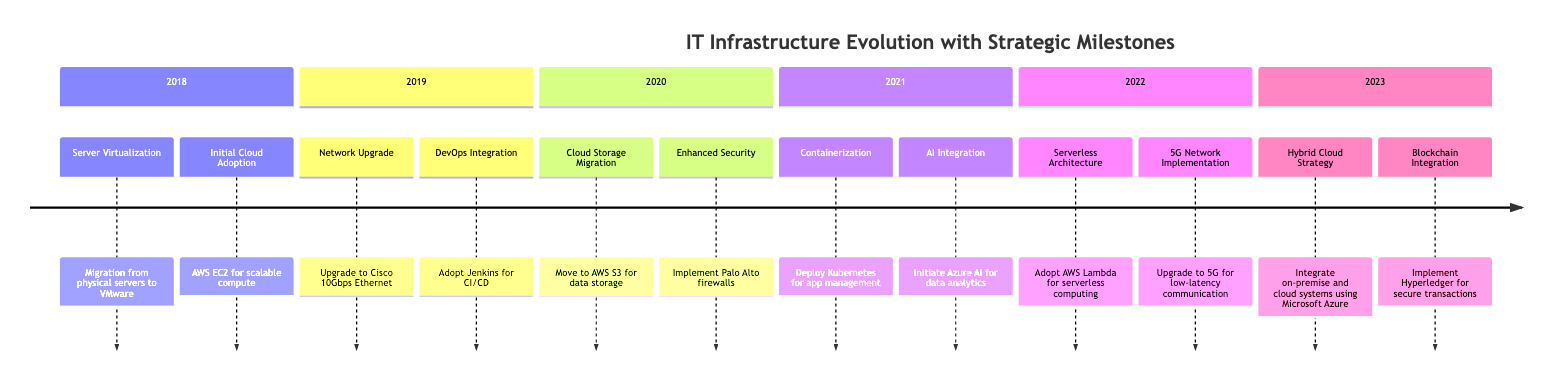What is the first key milestone in 2018? The first key milestone listed under the year 2018 is "Server Virtualization," which mentions the migration from physical servers to VMware.
Answer: Server Virtualization How many key milestones are there in 2021? In 2021, there are two key milestones indicated: "Containerization" and "AI Integration." Therefore, counting them gives a total of two milestones for that year.
Answer: 2 Which technology was adopted for serverless computing in 2022? The technology adopted for serverless computing in 2022 is indicated as "AWS Lambda," which is explicitly mentioned in the relevant section.
Answer: AWS Lambda What significant network technology was implemented in 2022? The significant network technology implemented in 2022, according to the diagram, is "5G Network Implementation," specifically aimed at achieving low-latency communication.
Answer: 5G Network Implementation In which year did cloud storage migration occur? The diagram specifies that cloud storage migration to "AWS S3 for data storage" occurred in the year 2020.
Answer: 2020 What does the hybrid cloud strategy integrate in 2023? The hybrid cloud strategy integrates "on-premise and cloud systems using Microsoft Azure," as stated in the 2023 section of the diagram.
Answer: on-premise and cloud systems using Microsoft Azure How does the 2019 milestone for network upgrade relate to DevOps integration? The 2019 milestones show "Network Upgrade" and "DevOps Integration" as separate milestones. The significance lies in both improvements enhancing system performance and development efficiency, indicating a strategy to upgrade and integrate operations.
Answer: Enhancing system performance and development efficiency What is the last technological advancement mentioned in the timeline? The last technological advancement mentioned in the timeline is "Blockchain Integration," which refers to the implementation of Hyperledger for secure transactions in the year 2023.
Answer: Blockchain Integration What approach was taken for data analytics integration in 2021? The diagram indicates that "Azure AI" was initiated for data analytics integration in 2021, representing the adoption of artificial intelligence for analytical purposes.
Answer: Azure AI 